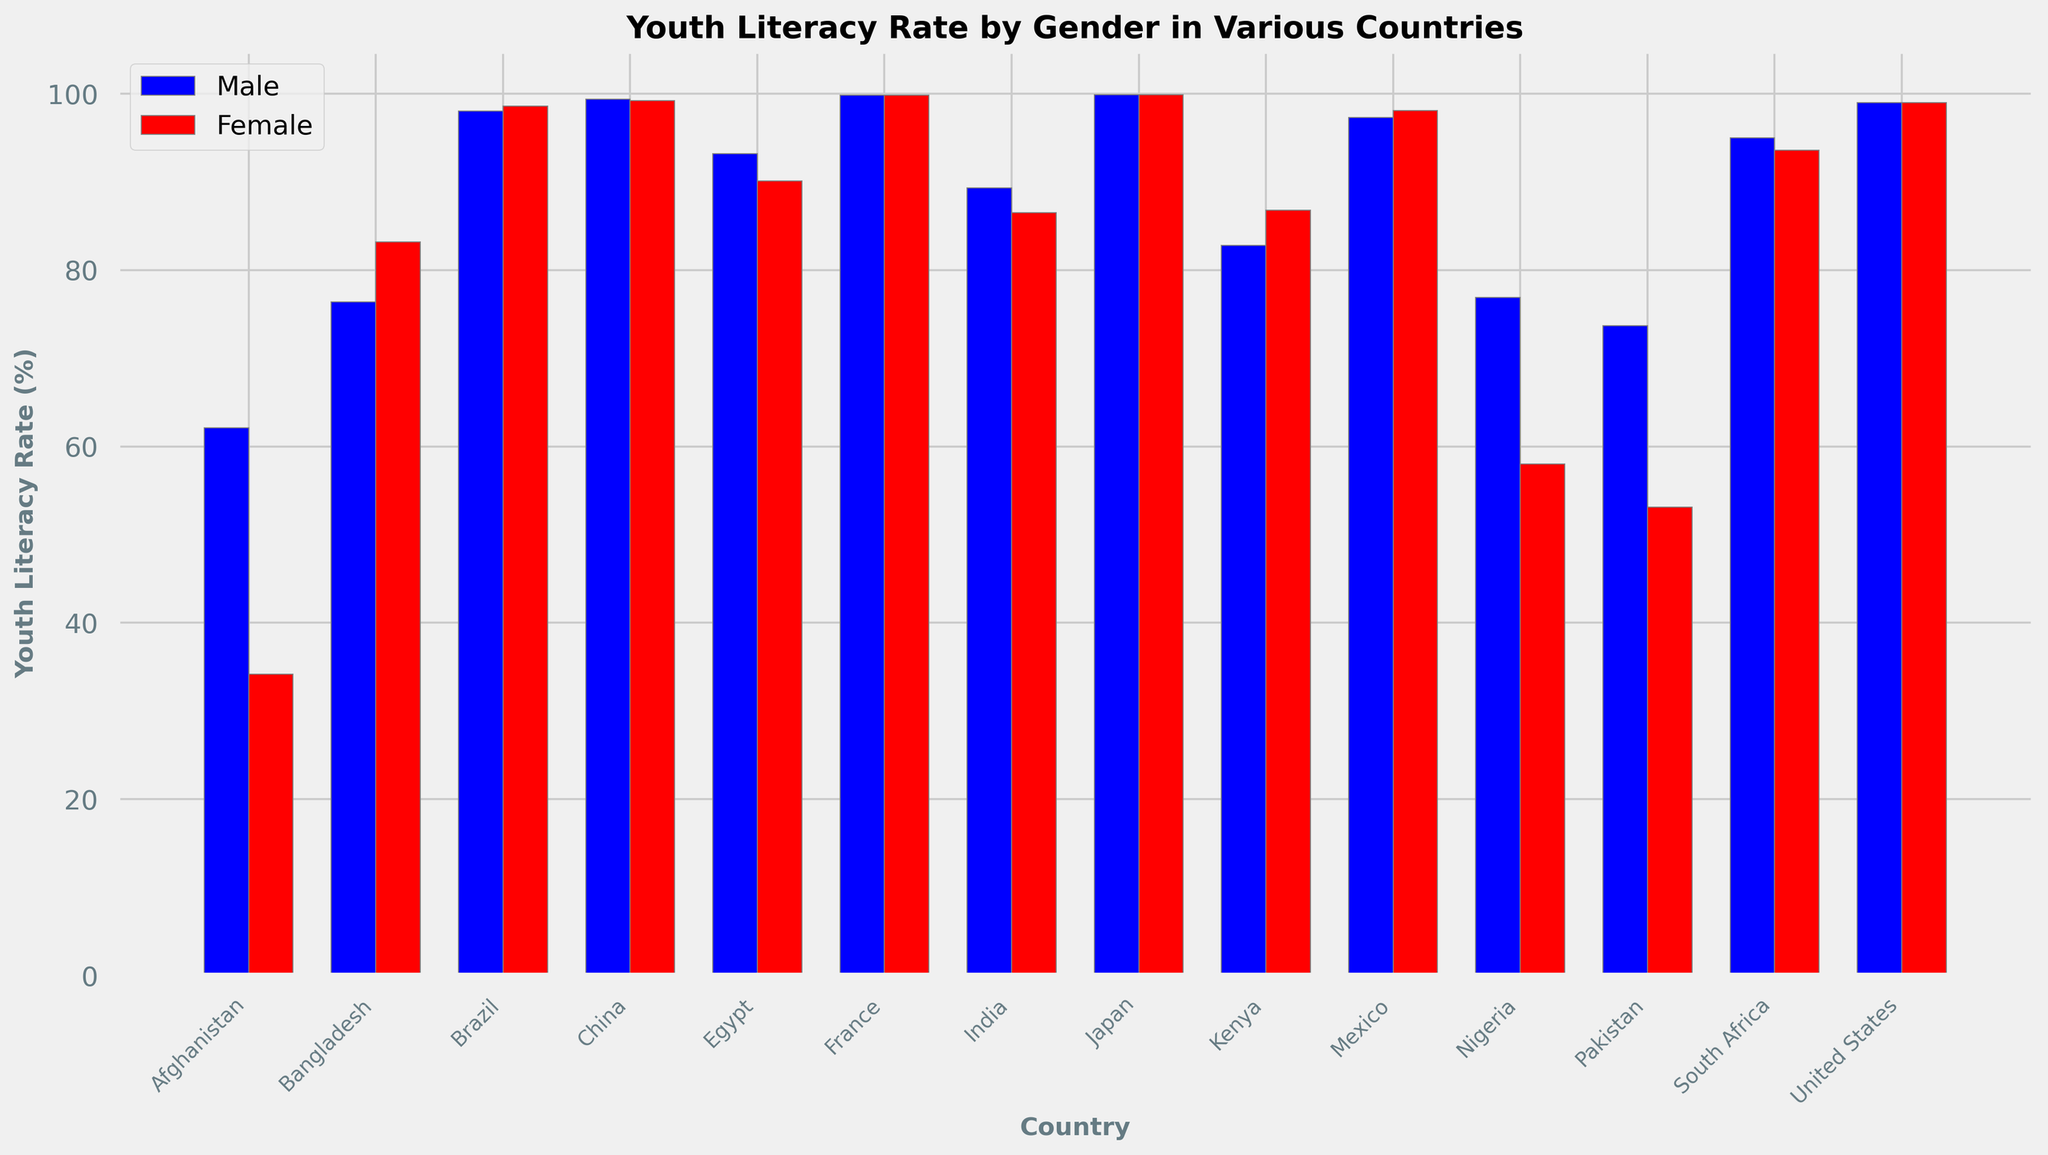Which country has the highest youth literacy rate for both genders? Look at the heights of both the blue and red bars for each country. Japan has the tallest bars for both males and females, indicating the highest youth literacy rates.
Answer: Japan Which country shows the largest gender discrepancy in youth literacy rates? Compare the male and female bars for each country to find the greatest difference. Afghanistan has the largest discrepancy, with a difference of 27.9% (62.1% for males and 34.2% for females).
Answer: Afghanistan In which country are the youth literacy rates nearly equal for males and females? Look for countries where the blue and red bars are almost the same height. In France, both male and female literacy rates are 99.8%, showing equality.
Answer: France How does the youth literacy rate for females in Nigeria compare to that in Pakistan? Compare the heights of the red bars for females in Nigeria and Pakistan. Nigeria's female literacy rate is 58.0%, which is higher than Pakistan's at 53.1%.
Answer: Nigeria has a higher rate What is the average youth literacy rate for females across all countries in the plot? Sum the youth literacy rates for females in each country and divide by the number of countries. The rates are 34.2, 83.2, 98.6, 99.2, 90.1, 99.8, 86.5, 99.9, 86.8, 98.1, 58.0, 53.1, 93.6, and 99.0, totaling 1179.1. There are 14 countries, so the average is 1179.1 / 14 = 84.2%.
Answer: 84.2% Which country has a higher youth literacy rate for females compared to males? Compare each pair of blue and red bars. Bangladesh, Brazil, Kenya, and Mexico have higher female literacy rates compared to males.
Answer: Bangladesh, Brazil, Kenya, Mexico Which country has the lowest youth literacy rate for males? Identify the shortest blue bar. Afghanistan has the lowest male literacy rate at 62.1%.
Answer: Afghanistan In how many countries are male literacy rates higher than female literacy rates? Count the countries where the blue bar is higher than the red bar. There are 7 countries: Afghanistan, China, Egypt, India, Nigeria, Pakistan, South Africa.
Answer: 7 Which two countries have identical youth literacy rates for both genders? Check countries where both blue and red bars are equal. France and Japan both have identical rates for males and females.
Answer: France and Japan By how much does the youth literacy rate for males in Egypt exceed that for females? Subtract the female literacy rate from the male literacy rate in Egypt: 93.2 - 90.1 = 3.1%.
Answer: 3.1% 